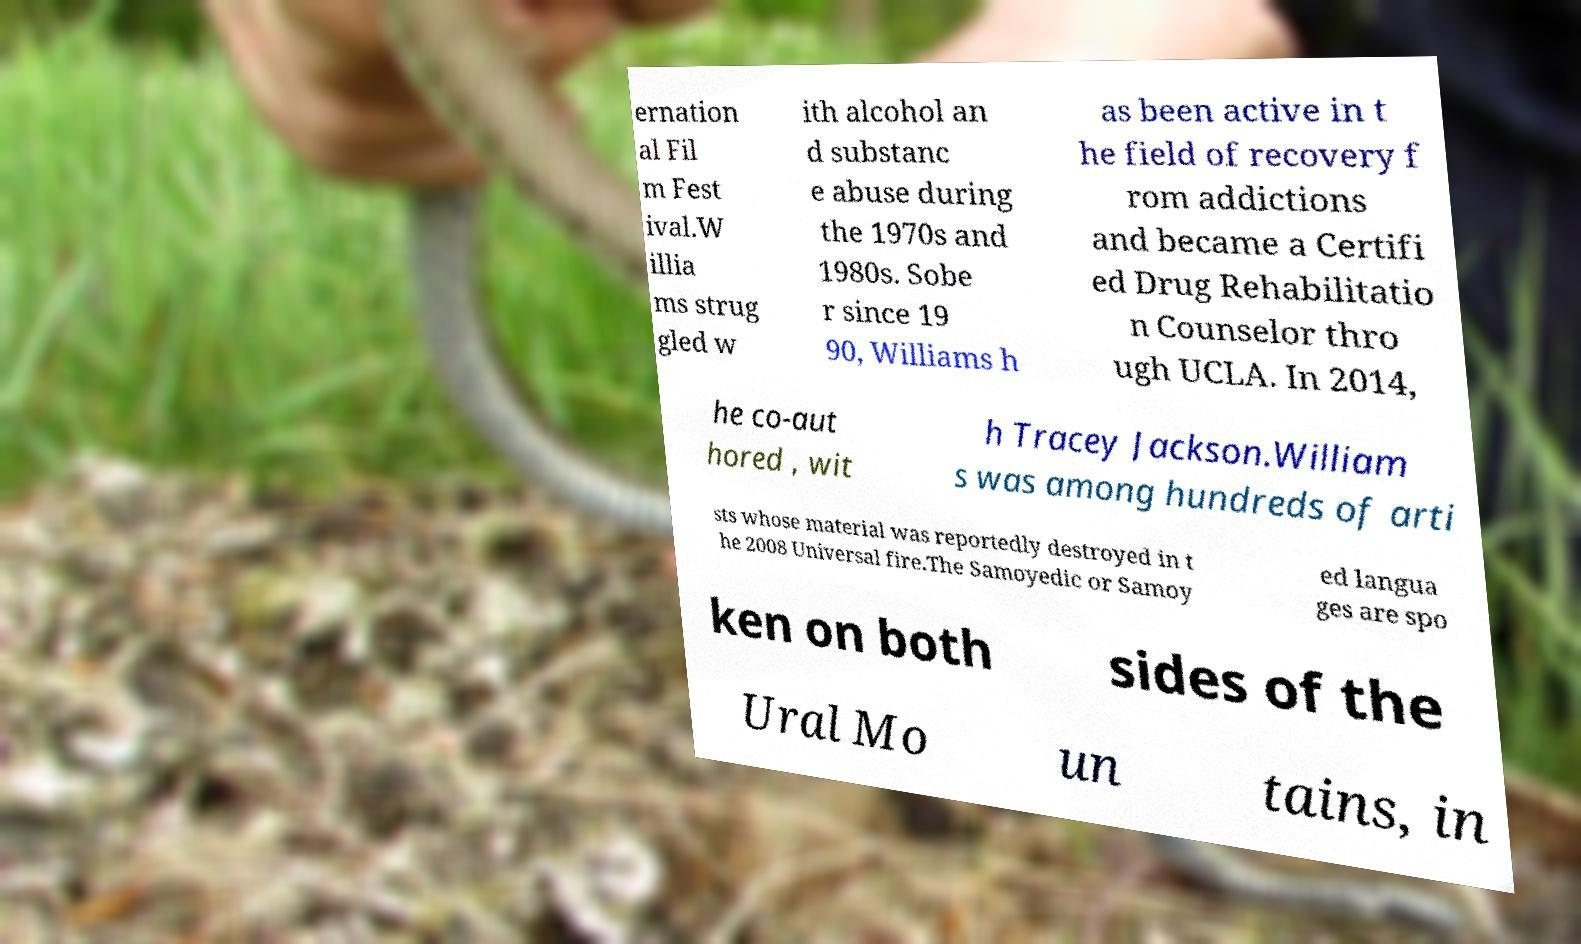What messages or text are displayed in this image? I need them in a readable, typed format. ernation al Fil m Fest ival.W illia ms strug gled w ith alcohol an d substanc e abuse during the 1970s and 1980s. Sobe r since 19 90, Williams h as been active in t he field of recovery f rom addictions and became a Certifi ed Drug Rehabilitatio n Counselor thro ugh UCLA. In 2014, he co-aut hored , wit h Tracey Jackson.William s was among hundreds of arti sts whose material was reportedly destroyed in t he 2008 Universal fire.The Samoyedic or Samoy ed langua ges are spo ken on both sides of the Ural Mo un tains, in 